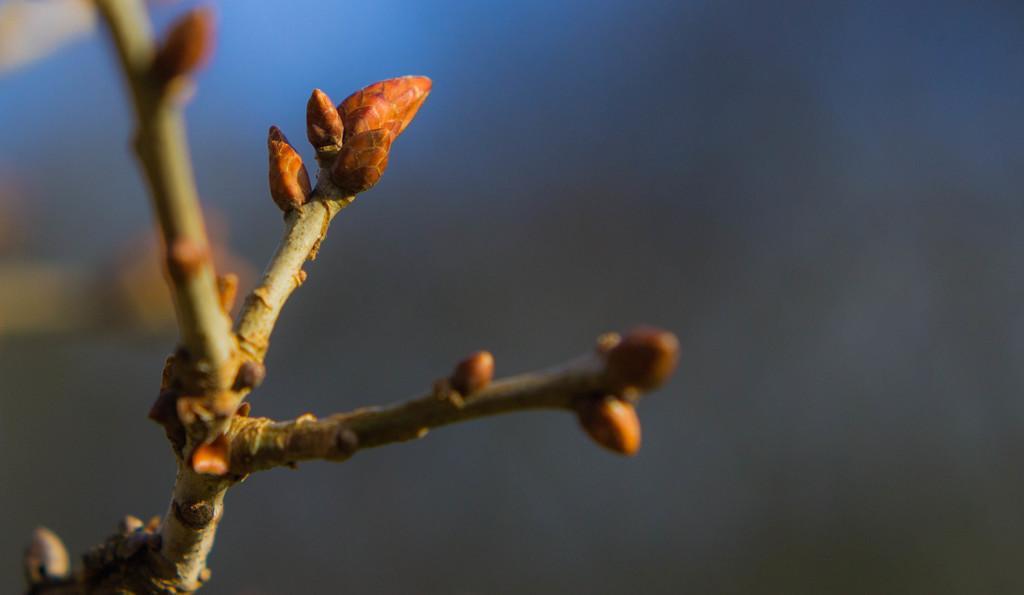In one or two sentences, can you explain what this image depicts? On the left side of the image, we can see stems with buds. In the background, there is a blur view. 